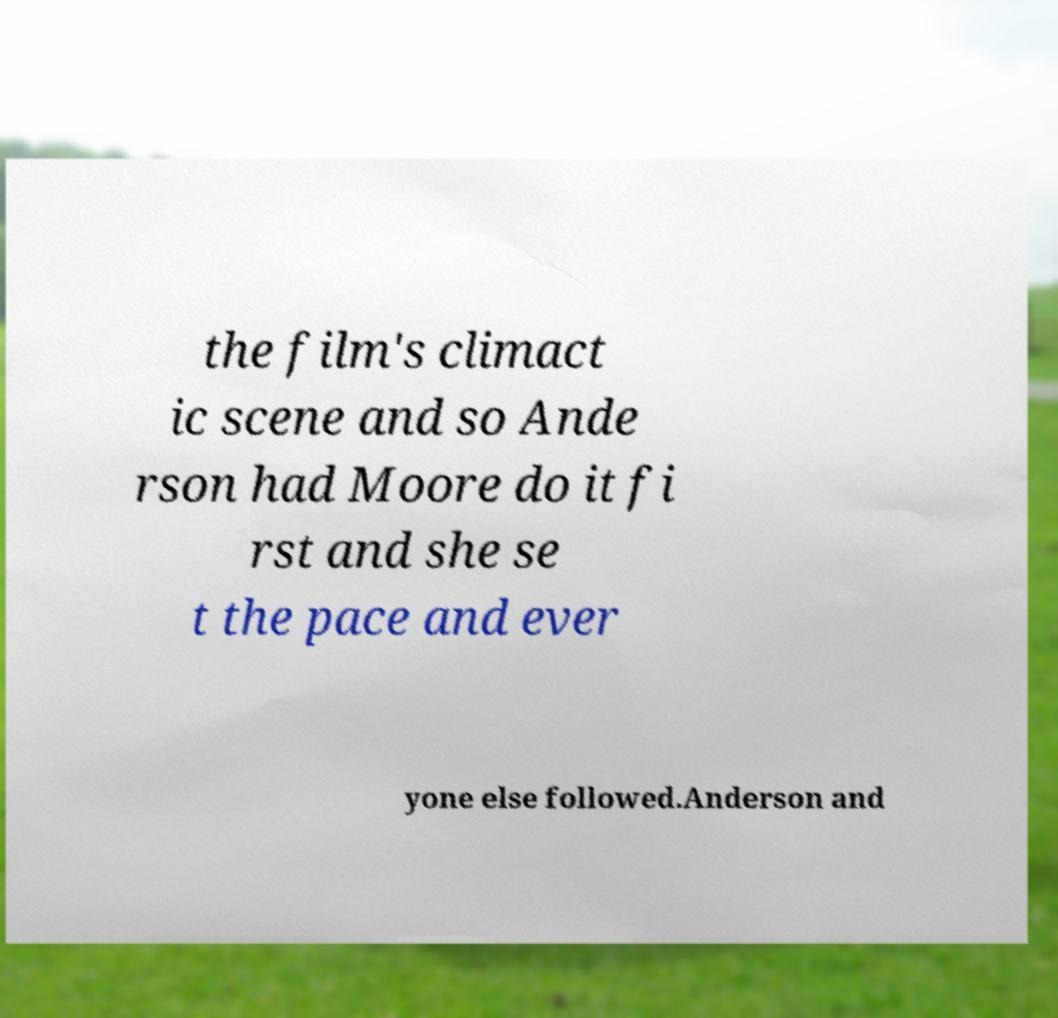I need the written content from this picture converted into text. Can you do that? the film's climact ic scene and so Ande rson had Moore do it fi rst and she se t the pace and ever yone else followed.Anderson and 